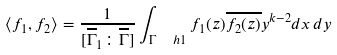Convert formula to latex. <formula><loc_0><loc_0><loc_500><loc_500>\langle f _ { 1 } , f _ { 2 } \rangle = \frac { 1 } { [ \overline { \Gamma } _ { 1 } \colon \overline { \Gamma } ] } \int _ { \Gamma \ \ h { 1 } } f _ { 1 } ( z ) \overline { f _ { 2 } ( z ) } y ^ { k - 2 } d x \, d y</formula> 